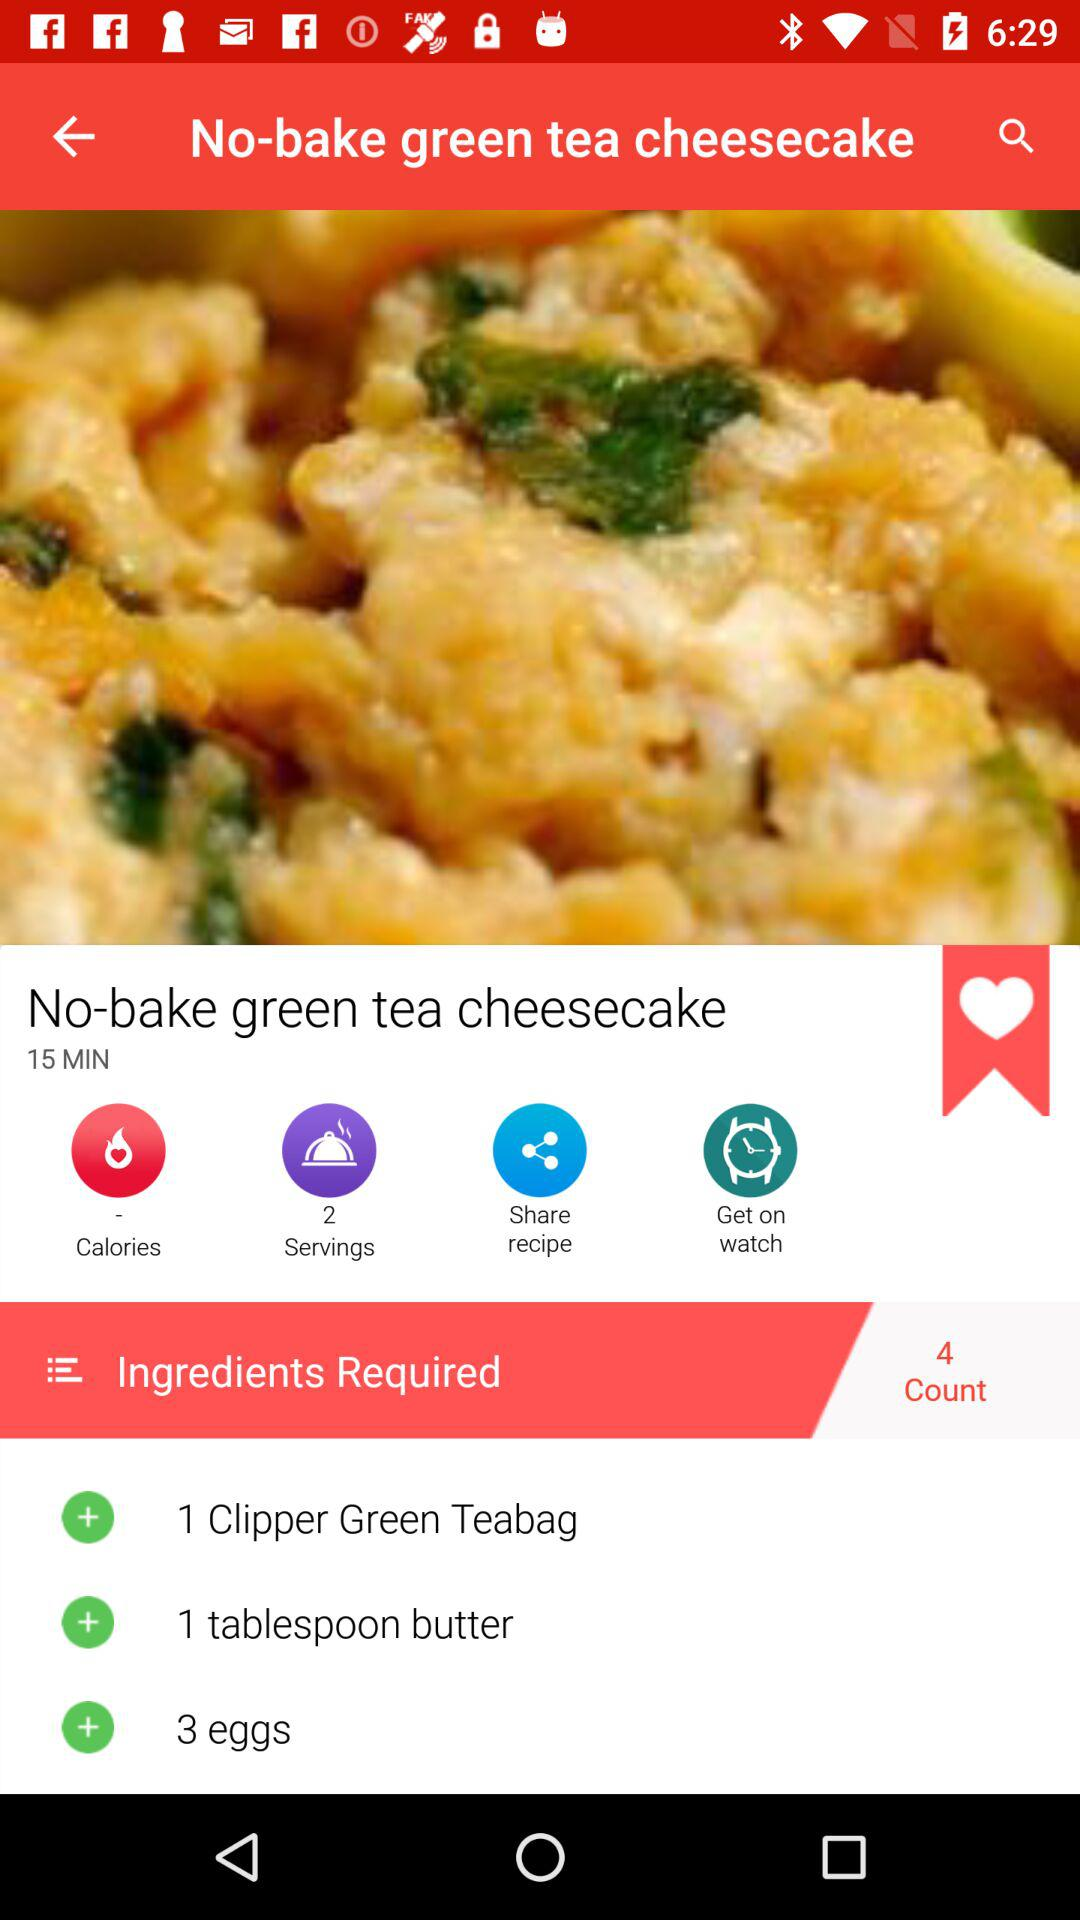What is the cooking time for "No-bake green tea cheesecake"? The cooking time is 15 minutes. 